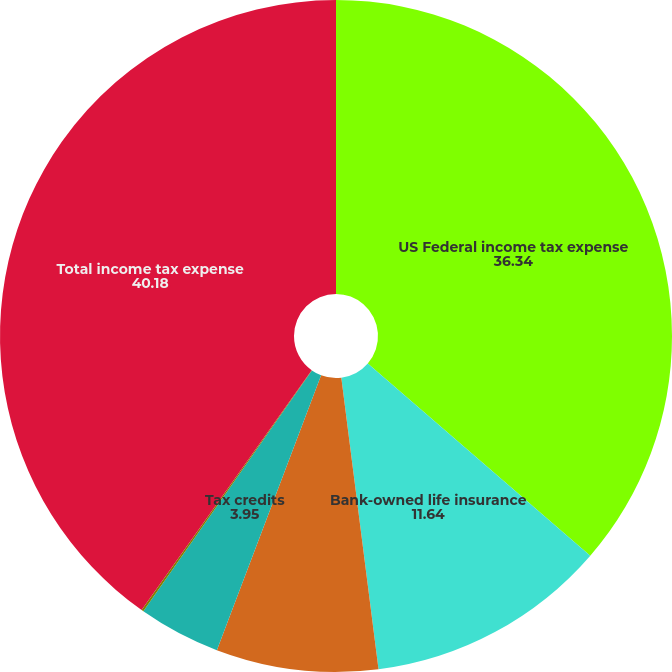Convert chart to OTSL. <chart><loc_0><loc_0><loc_500><loc_500><pie_chart><fcel>US Federal income tax expense<fcel>Bank-owned life insurance<fcel>Tax-exempt interest<fcel>Tax credits<fcel>Other<fcel>Total income tax expense<nl><fcel>36.34%<fcel>11.64%<fcel>7.79%<fcel>3.95%<fcel>0.1%<fcel>40.18%<nl></chart> 